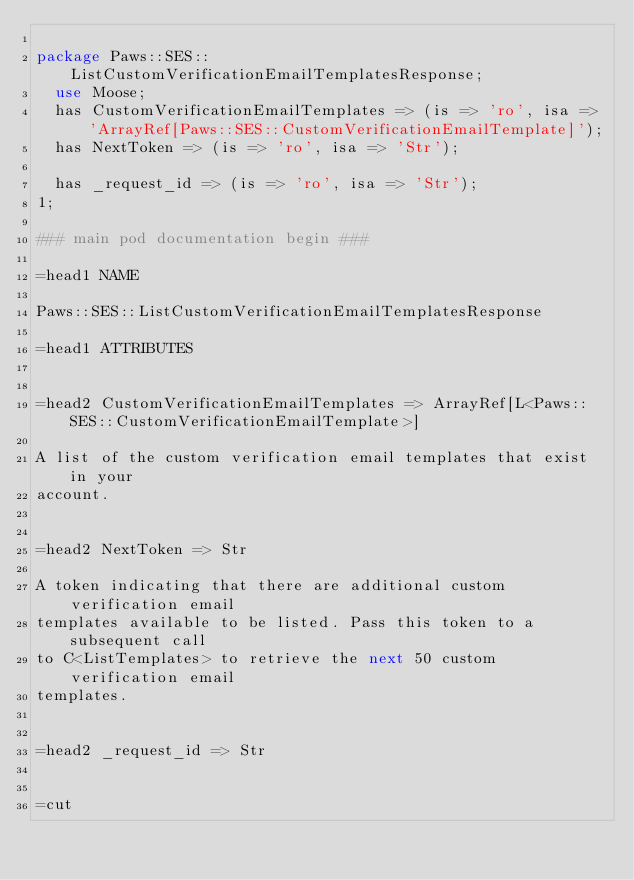<code> <loc_0><loc_0><loc_500><loc_500><_Perl_>
package Paws::SES::ListCustomVerificationEmailTemplatesResponse;
  use Moose;
  has CustomVerificationEmailTemplates => (is => 'ro', isa => 'ArrayRef[Paws::SES::CustomVerificationEmailTemplate]');
  has NextToken => (is => 'ro', isa => 'Str');

  has _request_id => (is => 'ro', isa => 'Str');
1;

### main pod documentation begin ###

=head1 NAME

Paws::SES::ListCustomVerificationEmailTemplatesResponse

=head1 ATTRIBUTES


=head2 CustomVerificationEmailTemplates => ArrayRef[L<Paws::SES::CustomVerificationEmailTemplate>]

A list of the custom verification email templates that exist in your
account.


=head2 NextToken => Str

A token indicating that there are additional custom verification email
templates available to be listed. Pass this token to a subsequent call
to C<ListTemplates> to retrieve the next 50 custom verification email
templates.


=head2 _request_id => Str


=cut

</code> 